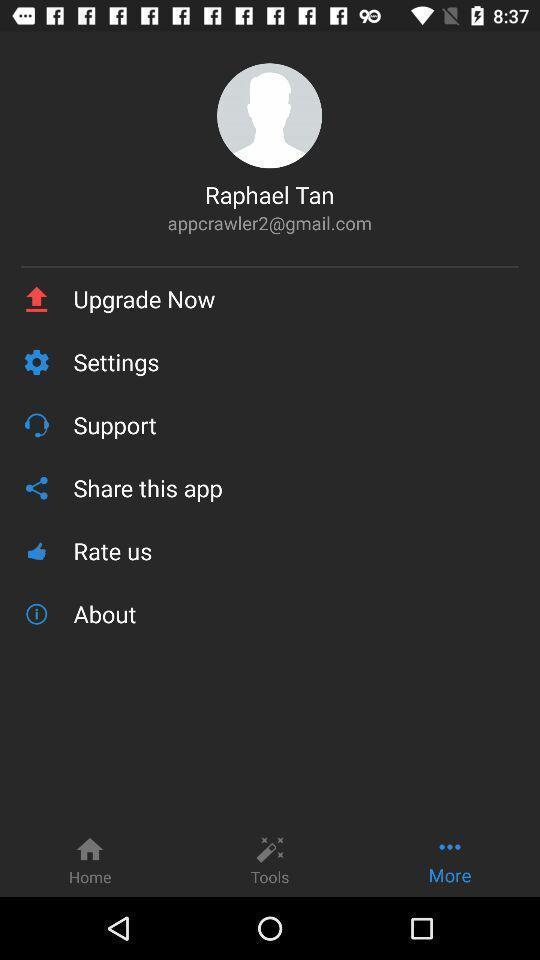Tell me what you see in this picture. Profile page with list of options. 